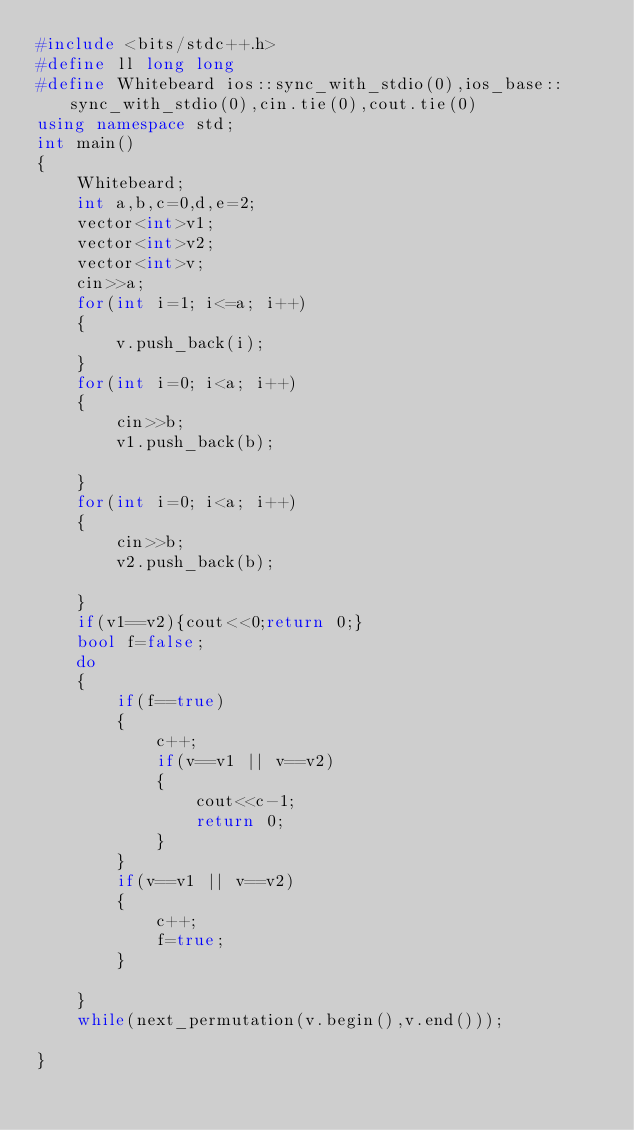Convert code to text. <code><loc_0><loc_0><loc_500><loc_500><_C++_>#include <bits/stdc++.h>
#define ll long long
#define Whitebeard ios::sync_with_stdio(0),ios_base::sync_with_stdio(0),cin.tie(0),cout.tie(0)
using namespace std;
int main()
{
    Whitebeard;
    int a,b,c=0,d,e=2;
    vector<int>v1;
    vector<int>v2;
    vector<int>v;
    cin>>a;
    for(int i=1; i<=a; i++)
    {
        v.push_back(i);
    }
    for(int i=0; i<a; i++)
    {
        cin>>b;
        v1.push_back(b);

    }
    for(int i=0; i<a; i++)
    {
        cin>>b;
        v2.push_back(b);

    }
    if(v1==v2){cout<<0;return 0;}
    bool f=false;
    do
    {
        if(f==true)
        {
            c++;
            if(v==v1 || v==v2)
            {
                cout<<c-1;
                return 0;
            }
        }
        if(v==v1 || v==v2)
        {
            c++;
            f=true;
        }

    }
    while(next_permutation(v.begin(),v.end()));

}
</code> 